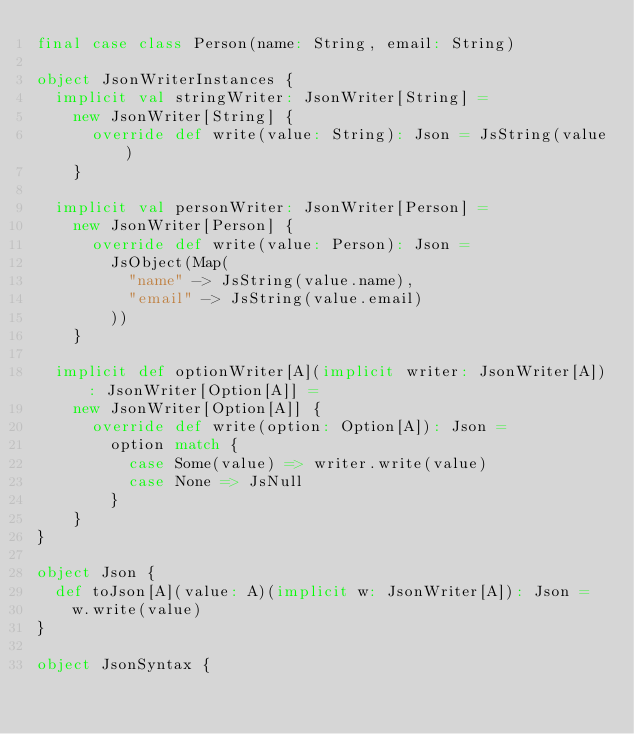Convert code to text. <code><loc_0><loc_0><loc_500><loc_500><_Scala_>final case class Person(name: String, email: String)

object JsonWriterInstances {
  implicit val stringWriter: JsonWriter[String] =
    new JsonWriter[String] {
      override def write(value: String): Json = JsString(value)
    }

  implicit val personWriter: JsonWriter[Person] =
    new JsonWriter[Person] {
      override def write(value: Person): Json =
        JsObject(Map(
          "name" -> JsString(value.name),
          "email" -> JsString(value.email)
        ))
    }

  implicit def optionWriter[A](implicit writer: JsonWriter[A]): JsonWriter[Option[A]] =
    new JsonWriter[Option[A]] {
      override def write(option: Option[A]): Json =
        option match {
          case Some(value) => writer.write(value)
          case None => JsNull
        }
    }
}

object Json {
  def toJson[A](value: A)(implicit w: JsonWriter[A]): Json =
    w.write(value)
}

object JsonSyntax {</code> 